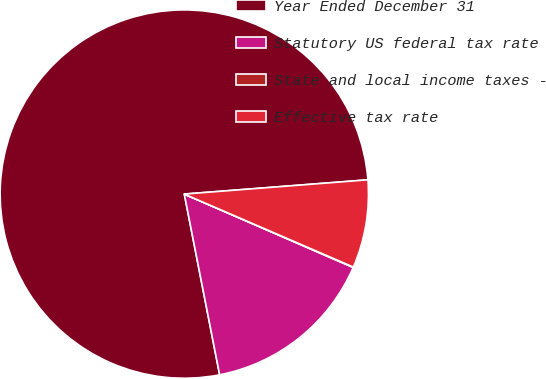Convert chart to OTSL. <chart><loc_0><loc_0><loc_500><loc_500><pie_chart><fcel>Year Ended December 31<fcel>Statutory US federal tax rate<fcel>State and local income taxes -<fcel>Effective tax rate<nl><fcel>76.84%<fcel>15.4%<fcel>0.04%<fcel>7.72%<nl></chart> 